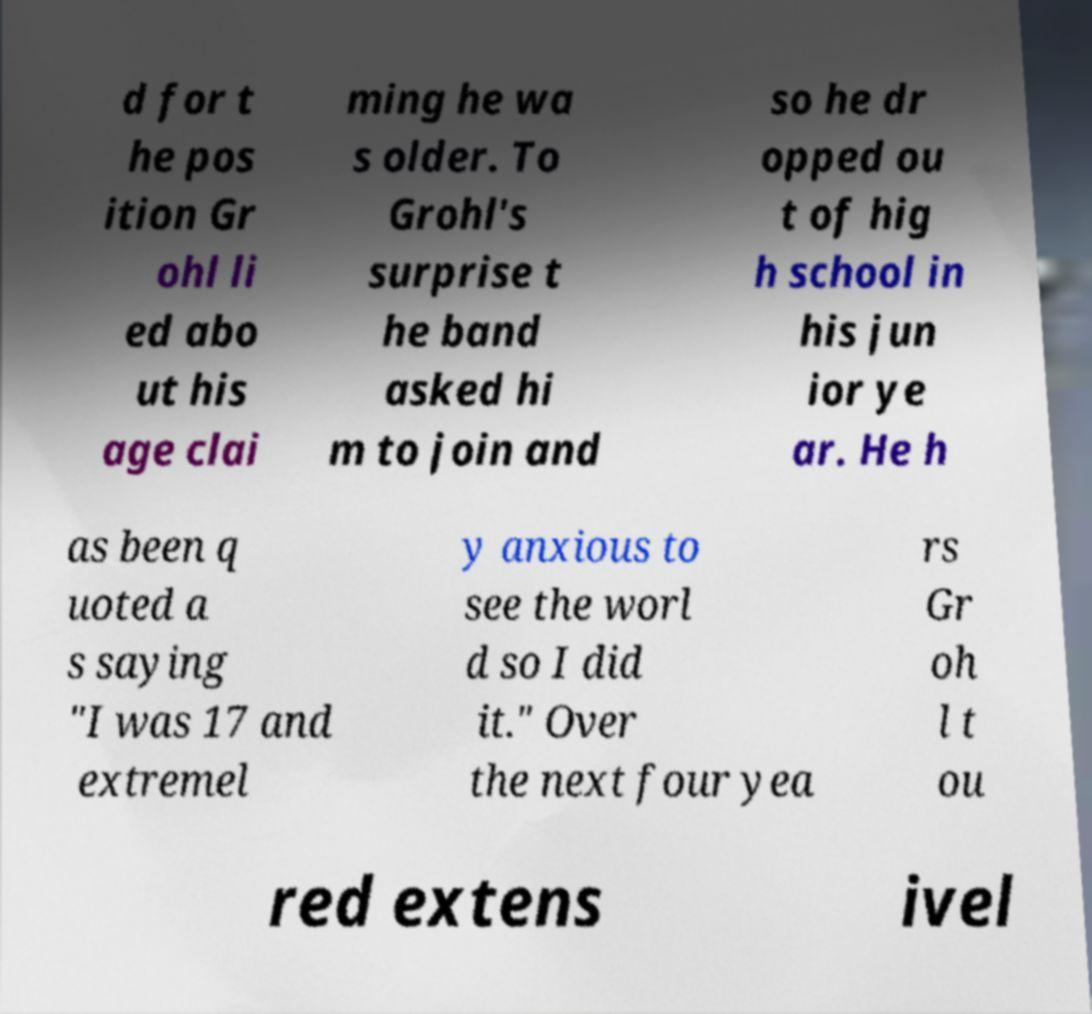I need the written content from this picture converted into text. Can you do that? d for t he pos ition Gr ohl li ed abo ut his age clai ming he wa s older. To Grohl's surprise t he band asked hi m to join and so he dr opped ou t of hig h school in his jun ior ye ar. He h as been q uoted a s saying "I was 17 and extremel y anxious to see the worl d so I did it." Over the next four yea rs Gr oh l t ou red extens ivel 